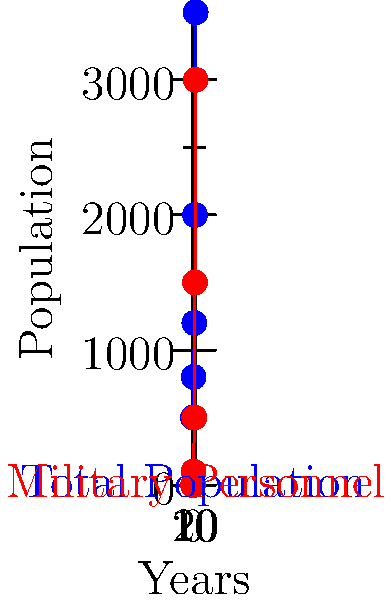The graph shows the transformation of a small village into a military base over 20 years. What percentage of the total population was military personnel at the 15-year mark? To solve this question, we need to follow these steps:

1. Identify the total population at the 15-year mark:
   From the blue line (Total Population), we can see that at 15 years, the population is 2000.

2. Identify the number of military personnel at the 15-year mark:
   From the red line (Military Personnel), we can see that at 15 years, there are 1500 military personnel.

3. Calculate the percentage of military personnel:
   Percentage = (Number of military personnel / Total population) × 100
   $$ \text{Percentage} = \frac{1500}{2000} \times 100 = 0.75 \times 100 = 75\% $$

Therefore, at the 15-year mark, 75% of the total population was military personnel.
Answer: 75% 